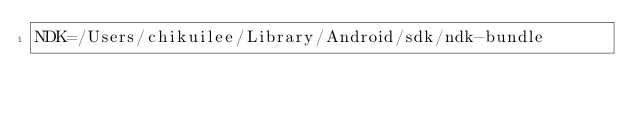Convert code to text. <code><loc_0><loc_0><loc_500><loc_500><_Bash_>NDK=/Users/chikuilee/Library/Android/sdk/ndk-bundle</code> 